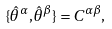Convert formula to latex. <formula><loc_0><loc_0><loc_500><loc_500>\{ \hat { \theta } ^ { \alpha } , \hat { \theta } ^ { \beta } \} = C ^ { \alpha \beta } ,</formula> 